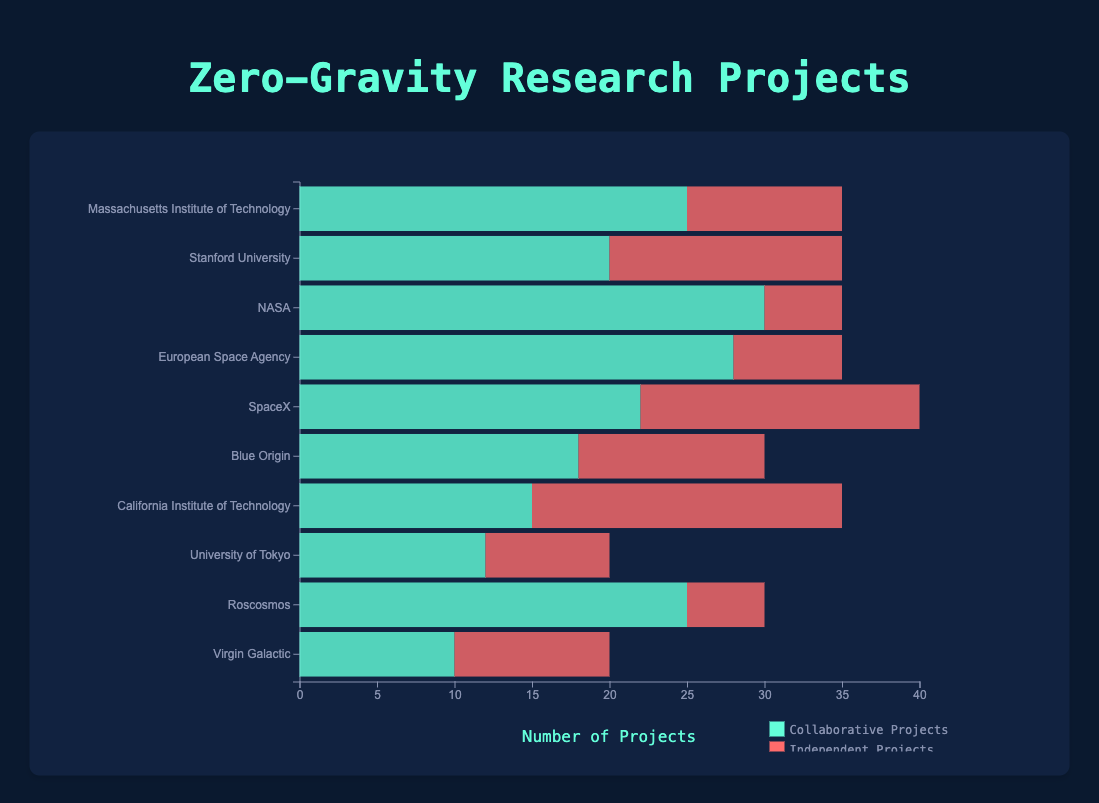Which institution has the highest number of collaborative projects? By looking at the length of the collaborative project bars, NASA has the longest bar for collaborative projects.
Answer: NASA Which institution type conducts more independent projects in total? Sum the independent projects for each institution type: University (10 + 15 + 20 + 8), Government Organization (5 + 7 + 5), Private Company (18 + 12 + 10). University: 53, Government Organization: 17, Private Company: 40. Universities conduct more independent projects.
Answer: University What is the average number of collaborative projects for private companies? Sum the collaborative projects for private companies (22 + 18 + 10) and divide by the number of private companies (3). (22 + 18 + 10) / 3 = 50 / 3 ≈ 16.67.
Answer: Approximately 16.67 Compare the total number of projects between the European Space Agency and Massachusetts Institute of Technology. Which one has more? Sum the collaborative and independent projects for each: European Space Agency (28 + 7 = 35), MIT (25 + 10 = 35). Both have the same number of projects.
Answer: Both are equal Which institution type has the highest proportion of collaborative projects? Calculate the proportion for each: University (25/35 + 20/35 + 15/35 + 12/20), Government Organization (30/35 + 28/35 + 25/30), Private Company (22/40 + 18/30 + 10/20). Government Organization has the highest average proportion.
Answer: Government Organization How many more collaborative projects does NASA have compared to Blue Origin? Subtract Blue Origin's collaborative projects from NASA's collaborative projects. 30 - 18 = 12.
Answer: 12 What is the total number of projects conducted by universities? Sum all projects for universities: (25 + 10) + (20 + 15) + (15 + 20) + (12 + 8). 35 + 35 + 35 + 20 = 125.
Answer: 125 Compare the collaborative and independent project ratio at SpaceX. Which one has a higher ratio? Calculate the ratio of collaborative to independent projects: 22/18 ≈ 1.22. Independent to collaborative: 18/22 ≈ 0.82. Collaborative projects have a higher ratio.
Answer: Collaborative Which institution has an equal number of collaborative and independent projects? By looking at the bar lengths, Virgin Galactic has 10 collaborative and 10 independent projects.
Answer: Virgin Galactic What is the difference in the total number of projects between Roscosmos and Stanford University? Sum the projects for both: Roscosmos (25 + 5 = 30), Stanford (20 + 15 = 35). 35 - 30 = 5.
Answer: 5 